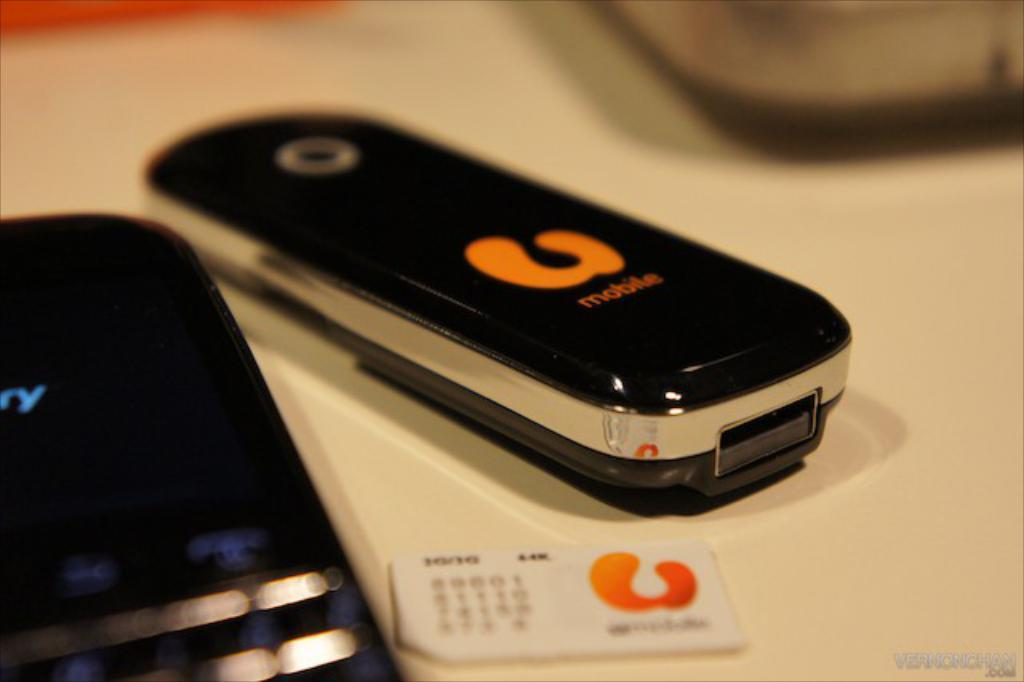<image>
Offer a succinct explanation of the picture presented. A closed flip phone has the word mobile written in orange letters. 